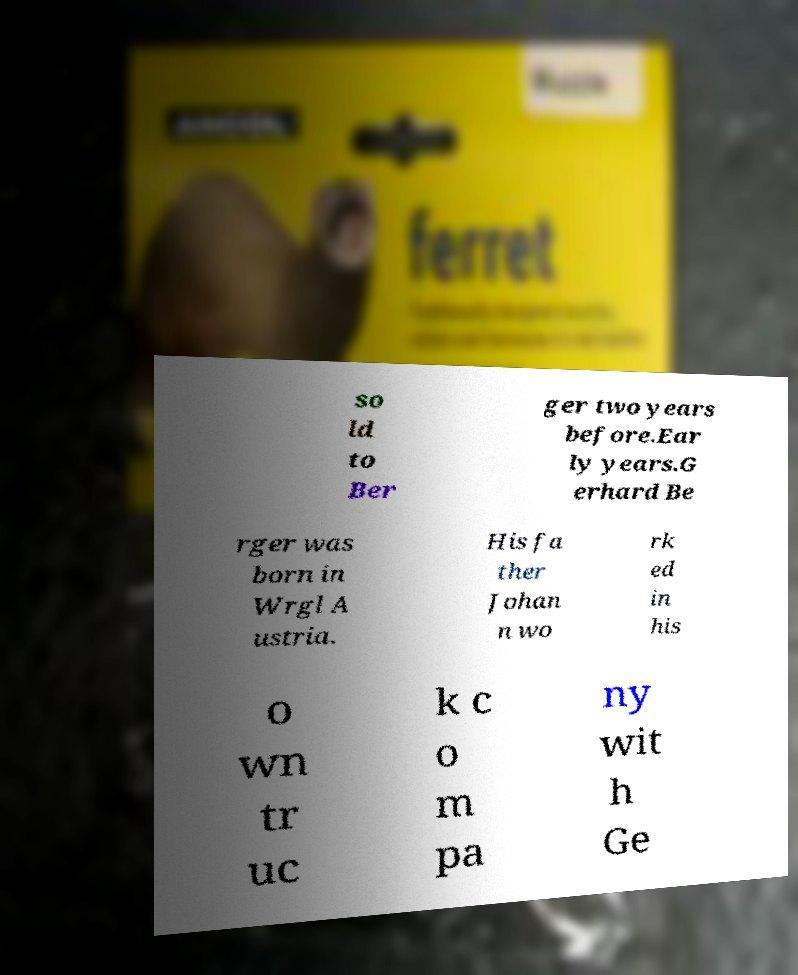Please read and relay the text visible in this image. What does it say? so ld to Ber ger two years before.Ear ly years.G erhard Be rger was born in Wrgl A ustria. His fa ther Johan n wo rk ed in his o wn tr uc k c o m pa ny wit h Ge 